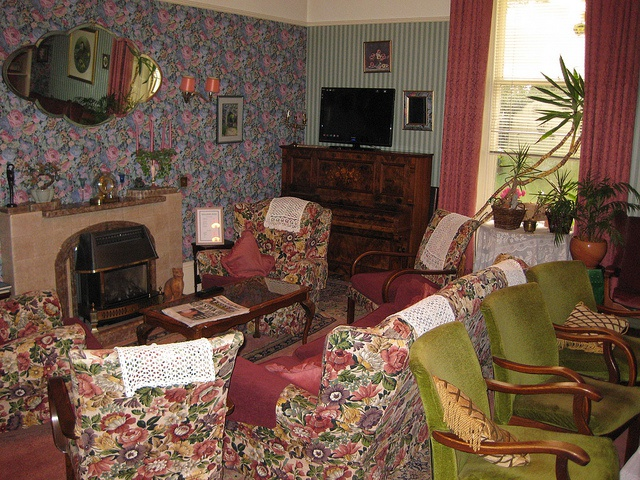Describe the objects in this image and their specific colors. I can see couch in black, brown, maroon, gray, and olive tones, chair in black, brown, white, and tan tones, couch in black, brown, white, and tan tones, chair in black, olive, and maroon tones, and chair in black, olive, and maroon tones in this image. 